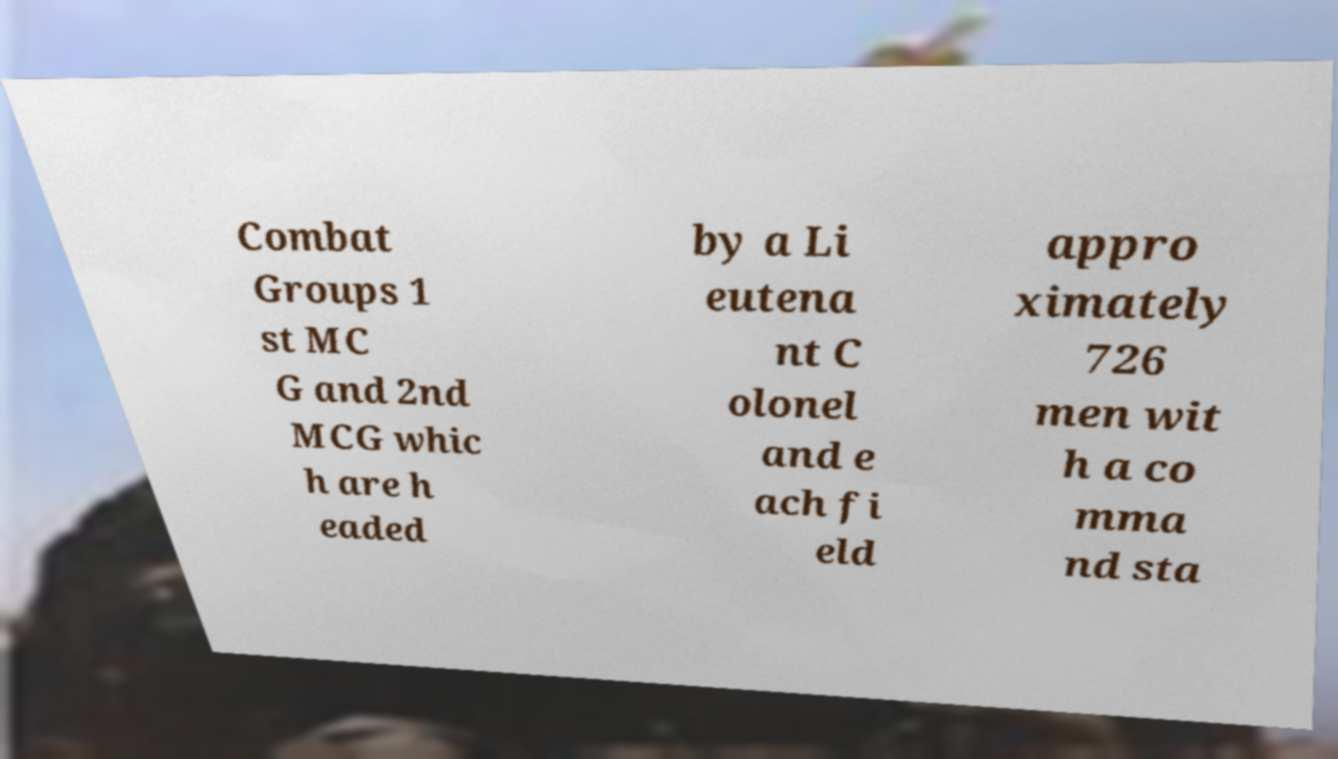For documentation purposes, I need the text within this image transcribed. Could you provide that? Combat Groups 1 st MC G and 2nd MCG whic h are h eaded by a Li eutena nt C olonel and e ach fi eld appro ximately 726 men wit h a co mma nd sta 